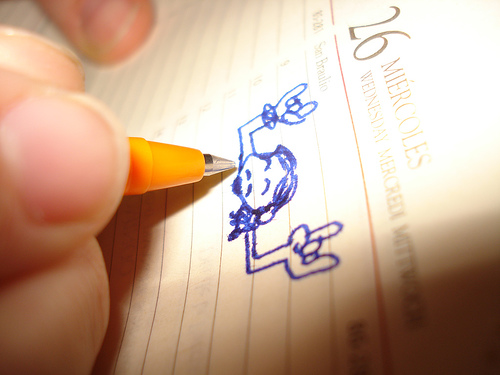<image>
Is the pen under the finger? Yes. The pen is positioned underneath the finger, with the finger above it in the vertical space. Is there a drawing under the pen? Yes. The drawing is positioned underneath the pen, with the pen above it in the vertical space. 